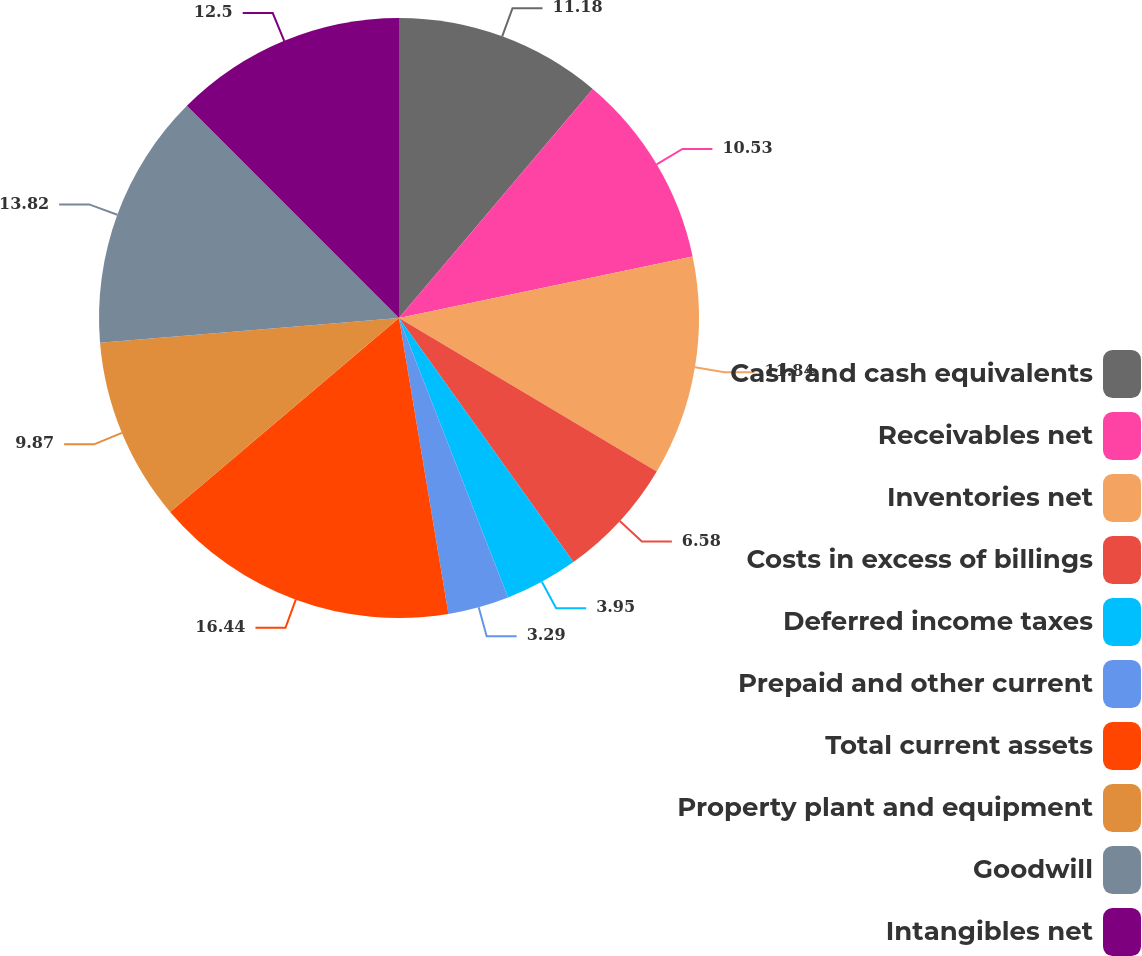Convert chart. <chart><loc_0><loc_0><loc_500><loc_500><pie_chart><fcel>Cash and cash equivalents<fcel>Receivables net<fcel>Inventories net<fcel>Costs in excess of billings<fcel>Deferred income taxes<fcel>Prepaid and other current<fcel>Total current assets<fcel>Property plant and equipment<fcel>Goodwill<fcel>Intangibles net<nl><fcel>11.18%<fcel>10.53%<fcel>11.84%<fcel>6.58%<fcel>3.95%<fcel>3.29%<fcel>16.45%<fcel>9.87%<fcel>13.82%<fcel>12.5%<nl></chart> 